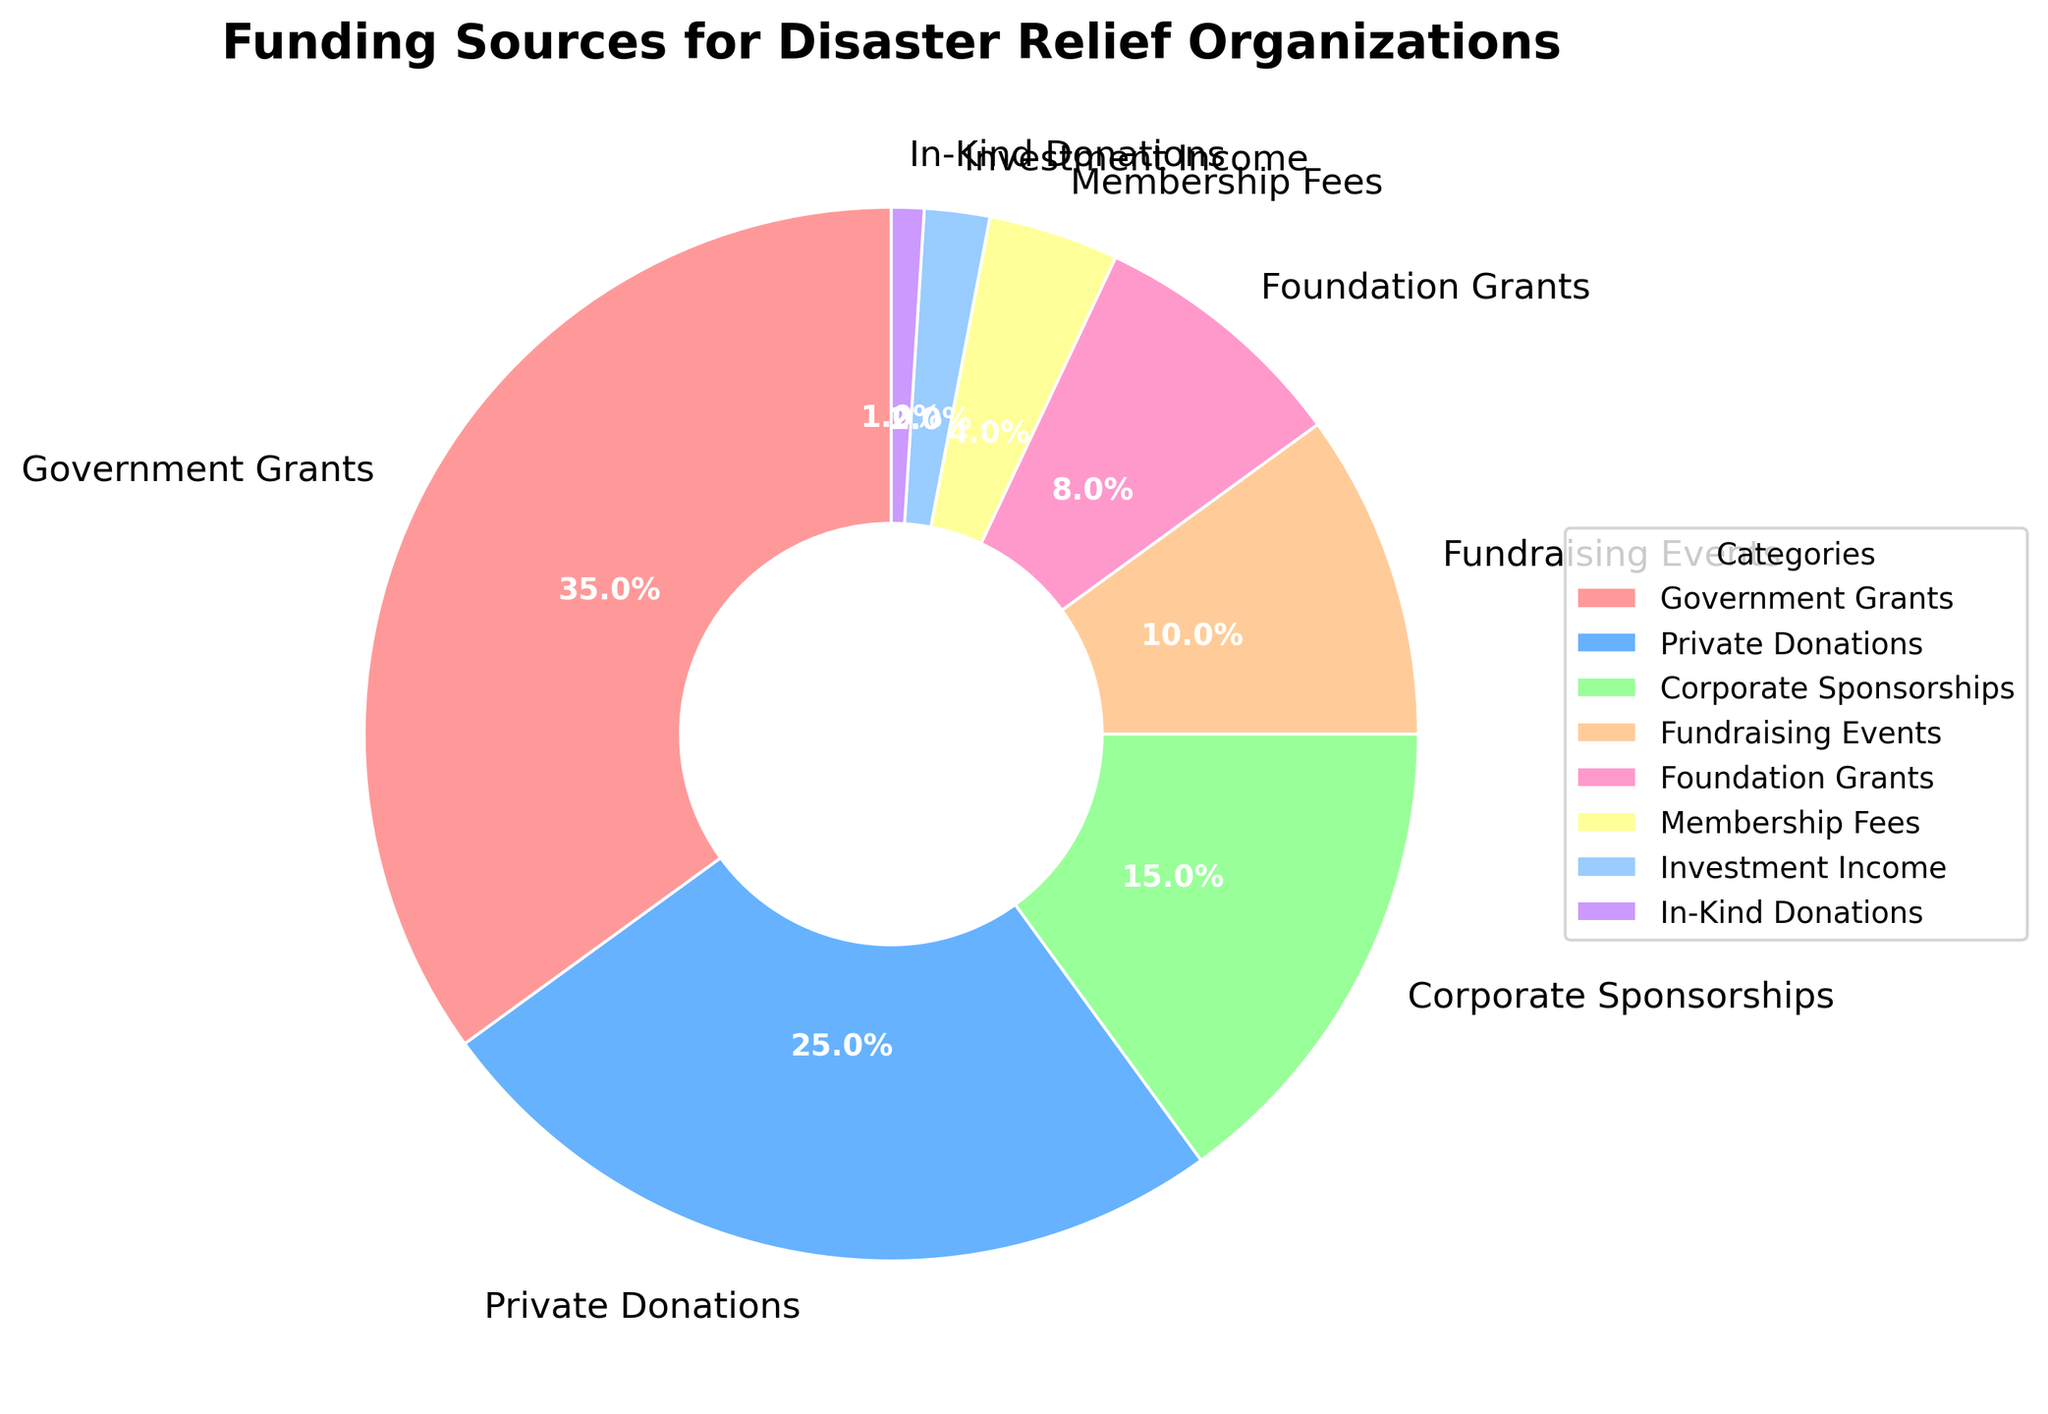What percentage of funding comes from Government Grants? The figure shows a section labeled "Government Grants," and its percentage is displayed next to it.
Answer: 35% Which category contributes the least to the funding? The smallest section in the pie chart is labeled "In-Kind Donations," with a very small percentage.
Answer: 1% What is the total percentage contributed by Private Donations and Fundraising Events? Private Donations contribute 25%, and Fundraising Events contribute 10%. Their total is 25% + 10%.
Answer: 35% Which funding source contributes more: Corporate Sponsorships or Foundation Grants? The pie chart shows Corporate Sponsorships at 15% and Foundation Grants at 8%.
Answer: Corporate Sponsorships How much more funding is obtained through Government Grants compared to Membership Fees? Government Grants contribute 35%, while Membership Fees contribute 4%. The difference is 35% - 4%.
Answer: 31% Which three categories contribute the most to the funding? The largest sections are labeled Government Grants (35%), Private Donations (25%), and Corporate Sponsorships (15%).
Answer: Government Grants, Private Donations, Corporate Sponsorships Combine the percentages of all funding sources that contribute less than 10%. What is their total percentage? The sources under 10% are Fundraising Events (10%), Foundation Grants (8%), Membership Fees (4%), Investment Income (2%), and In-Kind Donations (1%). Their total is 10% + 8% + 4% + 2% + 1%.
Answer: 25% Which category is represented by the blue slice? By referring to the color in the pie chart, the blue slice corresponds to Private Donations.
Answer: Private Donations What is the difference in percentage between the highest and lowest funding sources? The highest funding source is Government Grants at 35%, and the lowest is In-Kind Donations at 1%. The difference is 35% - 1%.
Answer: 34% What is the average percentage of Contribution from Corporate Sponsorships, Fundraising Events, and Foundation Grants combined? Corporate Sponsorships contribute 15%, Fundraising Events 10%, and Foundation Grants 8%. The total is 15% + 10% + 8% = 33%. The average is 33% / 3.
Answer: 11% 